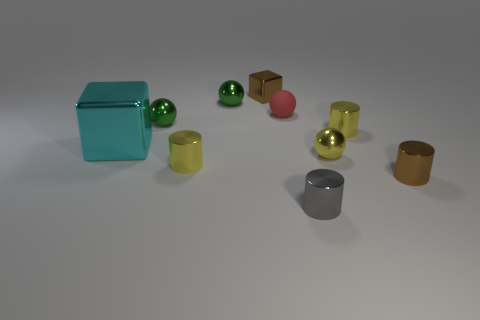Subtract 2 cylinders. How many cylinders are left? 2 Subtract all yellow spheres. How many spheres are left? 3 Subtract all gray shiny cylinders. How many cylinders are left? 3 Subtract all brown balls. Subtract all gray cylinders. How many balls are left? 4 Subtract all cubes. How many objects are left? 8 Add 1 small red rubber spheres. How many small red rubber spheres are left? 2 Add 5 rubber objects. How many rubber objects exist? 6 Subtract 0 green blocks. How many objects are left? 10 Subtract all metal spheres. Subtract all large objects. How many objects are left? 6 